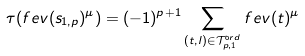<formula> <loc_0><loc_0><loc_500><loc_500>\tau ( f e v ( s _ { 1 , p } ) ^ { \mu } ) = ( - 1 ) ^ { p + 1 } \sum _ { ( t , l ) \in \mathcal { T } ^ { \mathrm o r d } _ { p , 1 } } f e v ( t ) ^ { \mu }</formula> 